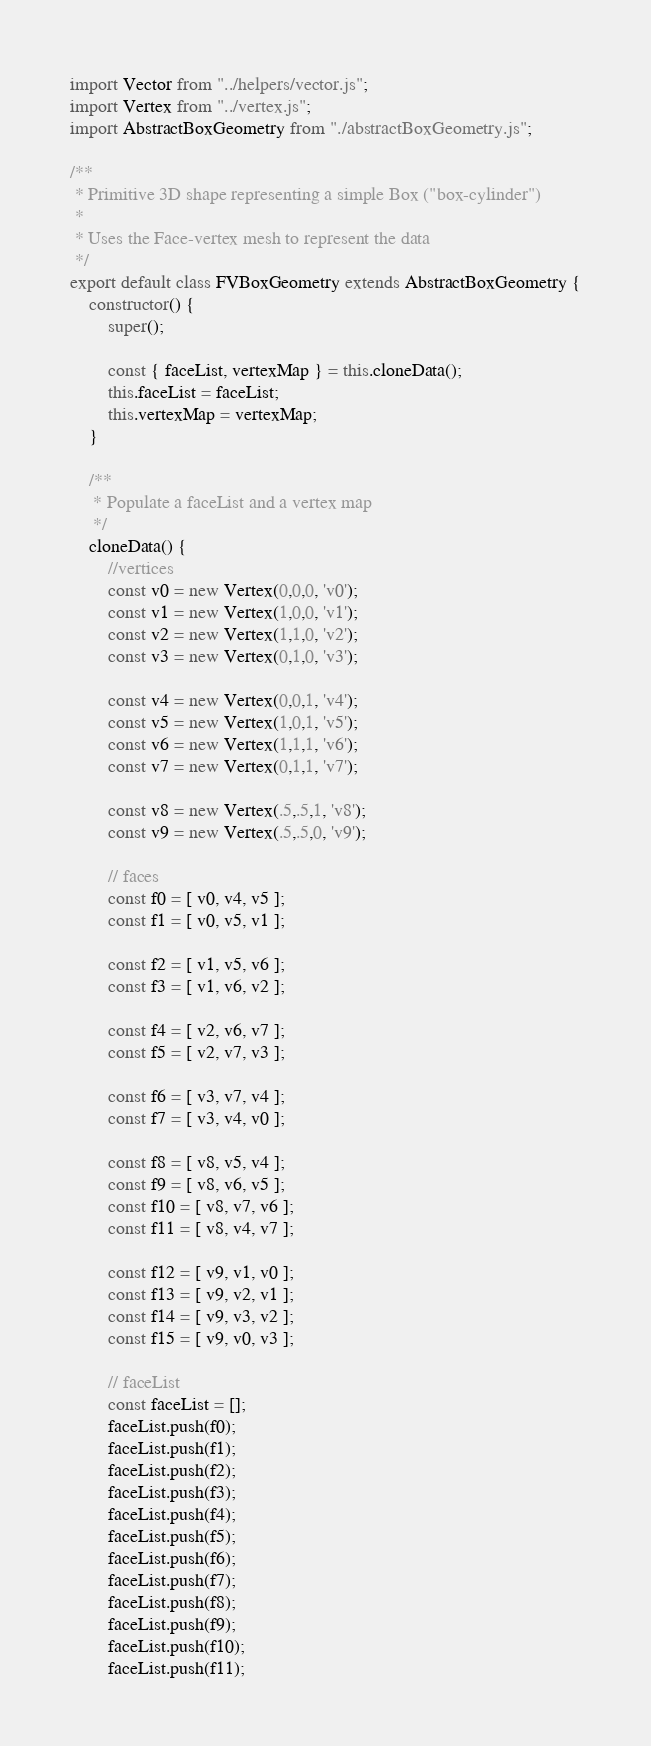Convert code to text. <code><loc_0><loc_0><loc_500><loc_500><_JavaScript_>import Vector from "../helpers/vector.js";
import Vertex from "../vertex.js";
import AbstractBoxGeometry from "./abstractBoxGeometry.js";

/**
 * Primitive 3D shape representing a simple Box ("box-cylinder")
 * 
 * Uses the Face-vertex mesh to represent the data
 */
export default class FVBoxGeometry extends AbstractBoxGeometry {
    constructor() {
        super();

        const { faceList, vertexMap } = this.cloneData();
        this.faceList = faceList;
        this.vertexMap = vertexMap;
    }

    /**
     * Populate a faceList and a vertex map
     */
    cloneData() {
        //vertices
        const v0 = new Vertex(0,0,0, 'v0');
        const v1 = new Vertex(1,0,0, 'v1');
        const v2 = new Vertex(1,1,0, 'v2');
        const v3 = new Vertex(0,1,0, 'v3');

        const v4 = new Vertex(0,0,1, 'v4');
        const v5 = new Vertex(1,0,1, 'v5');
        const v6 = new Vertex(1,1,1, 'v6');
        const v7 = new Vertex(0,1,1, 'v7');

        const v8 = new Vertex(.5,.5,1, 'v8');
        const v9 = new Vertex(.5,.5,0, 'v9');

        // faces
        const f0 = [ v0, v4, v5 ];
        const f1 = [ v0, v5, v1 ];

        const f2 = [ v1, v5, v6 ];
        const f3 = [ v1, v6, v2 ];

        const f4 = [ v2, v6, v7 ];
        const f5 = [ v2, v7, v3 ];

        const f6 = [ v3, v7, v4 ];
        const f7 = [ v3, v4, v0 ];

        const f8 = [ v8, v5, v4 ];
        const f9 = [ v8, v6, v5 ];
        const f10 = [ v8, v7, v6 ];
        const f11 = [ v8, v4, v7 ];

        const f12 = [ v9, v1, v0 ];
        const f13 = [ v9, v2, v1 ];
        const f14 = [ v9, v3, v2 ];
        const f15 = [ v9, v0, v3 ];

        // faceList
        const faceList = [];
        faceList.push(f0);
        faceList.push(f1);
        faceList.push(f2);
        faceList.push(f3);
        faceList.push(f4);
        faceList.push(f5);
        faceList.push(f6);
        faceList.push(f7);
        faceList.push(f8);
        faceList.push(f9);
        faceList.push(f10);
        faceList.push(f11);</code> 